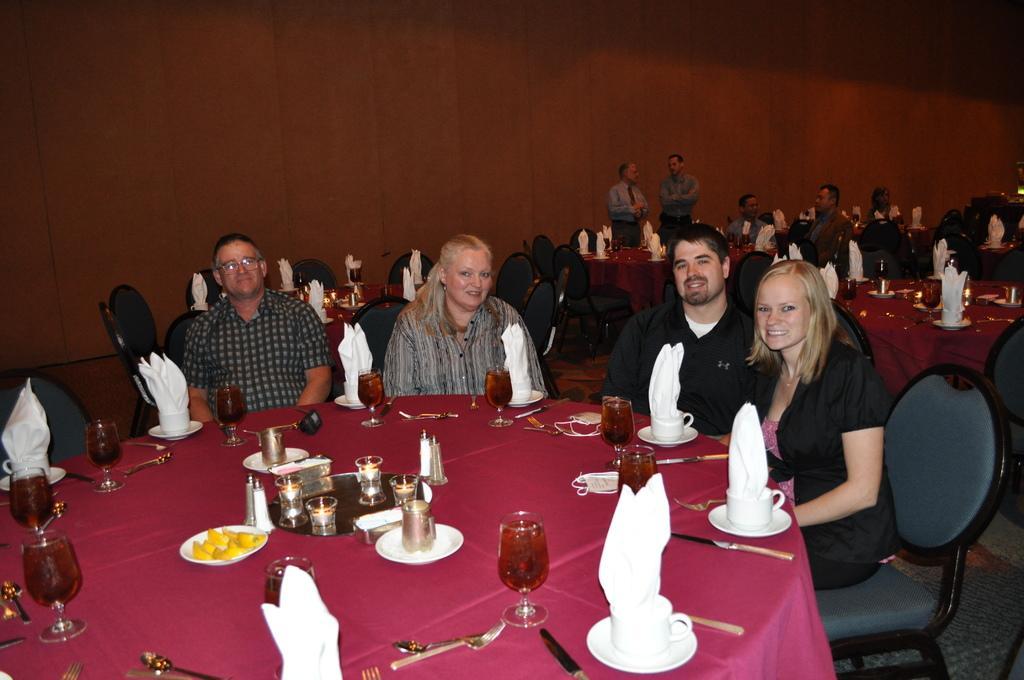Describe this image in one or two sentences. This image is clicked in a restaurant where there are so many tables and chairs. People are sitting on chair around the tables. On table there are plates, glasses, fork, spoon, knife, napkins. 